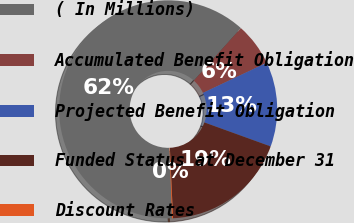<chart> <loc_0><loc_0><loc_500><loc_500><pie_chart><fcel>( In Millions)<fcel>Accumulated Benefit Obligation<fcel>Projected Benefit Obligation<fcel>Funded Status at December 31<fcel>Discount Rates<nl><fcel>62.19%<fcel>6.35%<fcel>12.55%<fcel>18.76%<fcel>0.15%<nl></chart> 